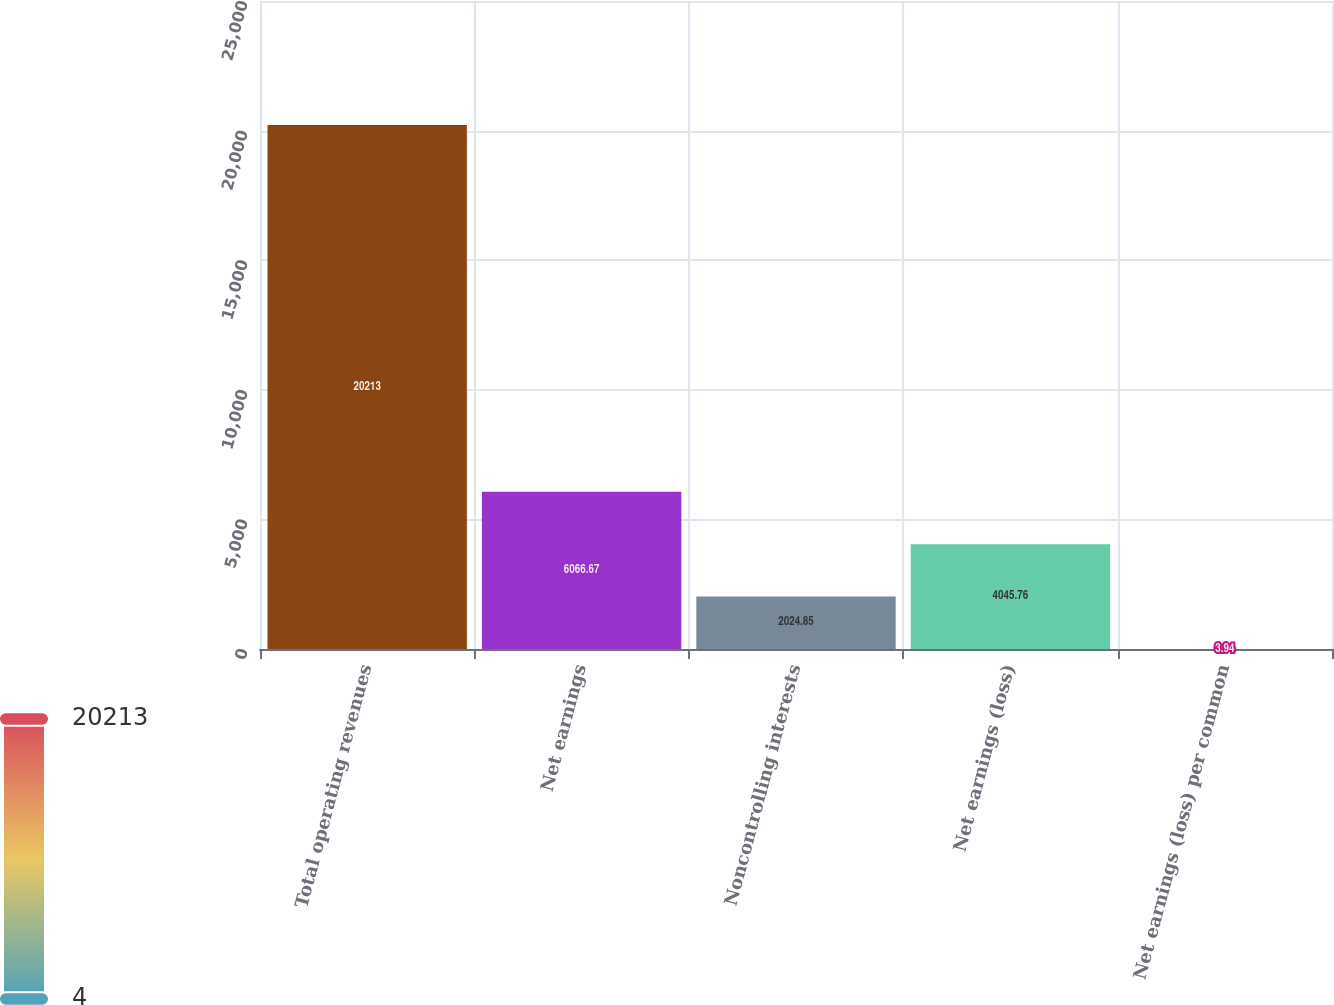Convert chart. <chart><loc_0><loc_0><loc_500><loc_500><bar_chart><fcel>Total operating revenues<fcel>Net earnings<fcel>Noncontrolling interests<fcel>Net earnings (loss)<fcel>Net earnings (loss) per common<nl><fcel>20213<fcel>6066.67<fcel>2024.85<fcel>4045.76<fcel>3.94<nl></chart> 